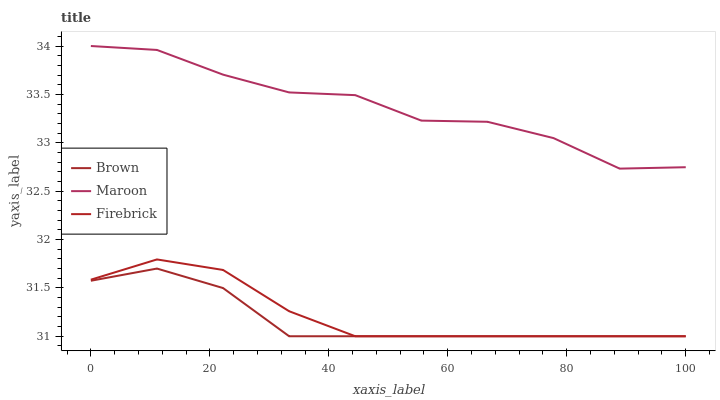Does Firebrick have the minimum area under the curve?
Answer yes or no. No. Does Firebrick have the maximum area under the curve?
Answer yes or no. No. Is Maroon the smoothest?
Answer yes or no. No. Is Firebrick the roughest?
Answer yes or no. No. Does Maroon have the lowest value?
Answer yes or no. No. Does Firebrick have the highest value?
Answer yes or no. No. Is Firebrick less than Maroon?
Answer yes or no. Yes. Is Maroon greater than Firebrick?
Answer yes or no. Yes. Does Firebrick intersect Maroon?
Answer yes or no. No. 